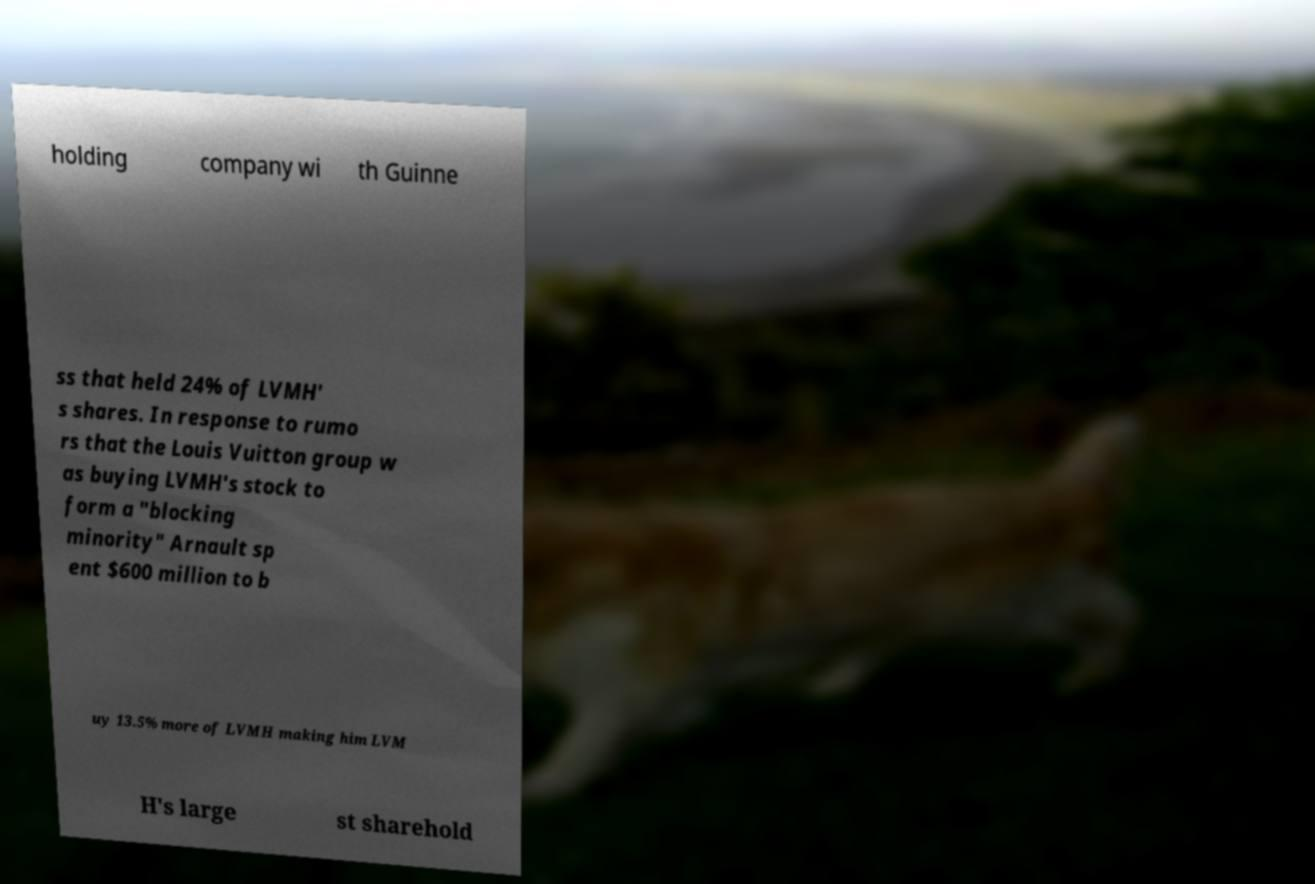Can you accurately transcribe the text from the provided image for me? holding company wi th Guinne ss that held 24% of LVMH' s shares. In response to rumo rs that the Louis Vuitton group w as buying LVMH's stock to form a "blocking minority" Arnault sp ent $600 million to b uy 13.5% more of LVMH making him LVM H's large st sharehold 